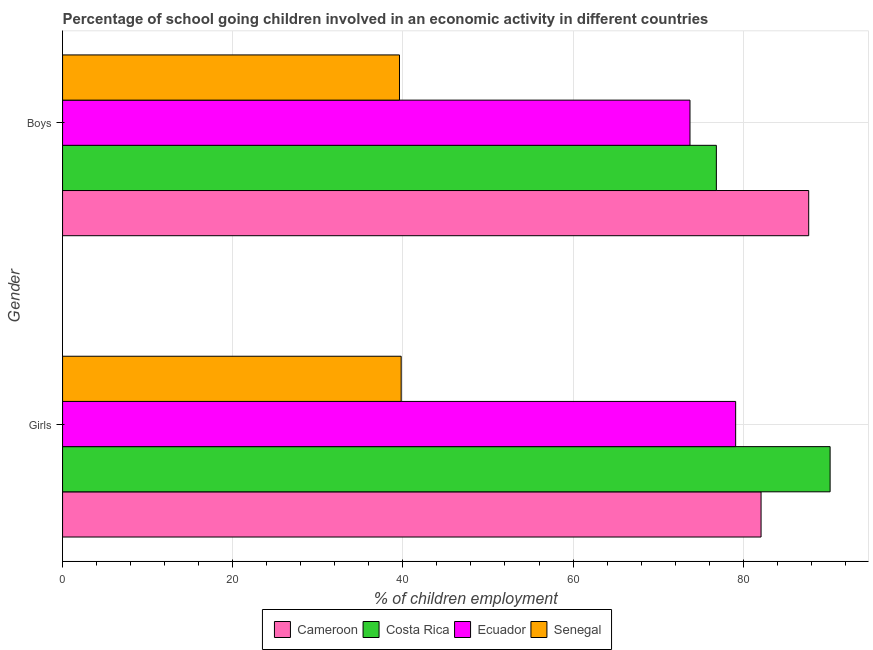Are the number of bars per tick equal to the number of legend labels?
Your response must be concise. Yes. Are the number of bars on each tick of the Y-axis equal?
Your response must be concise. Yes. What is the label of the 2nd group of bars from the top?
Ensure brevity in your answer.  Girls. What is the percentage of school going boys in Cameroon?
Give a very brief answer. 87.7. Across all countries, what is the maximum percentage of school going boys?
Offer a very short reply. 87.7. Across all countries, what is the minimum percentage of school going girls?
Provide a succinct answer. 39.8. In which country was the percentage of school going boys maximum?
Make the answer very short. Cameroon. In which country was the percentage of school going girls minimum?
Offer a terse response. Senegal. What is the total percentage of school going girls in the graph?
Provide a succinct answer. 291.23. What is the difference between the percentage of school going boys in Ecuador and that in Costa Rica?
Offer a very short reply. -3.1. What is the difference between the percentage of school going girls in Cameroon and the percentage of school going boys in Ecuador?
Give a very brief answer. 8.35. What is the average percentage of school going boys per country?
Provide a succinct answer. 69.47. What is the difference between the percentage of school going girls and percentage of school going boys in Ecuador?
Your response must be concise. 5.37. What is the ratio of the percentage of school going girls in Ecuador to that in Senegal?
Give a very brief answer. 1.99. What does the 2nd bar from the top in Girls represents?
Provide a succinct answer. Ecuador. What does the 3rd bar from the bottom in Boys represents?
Your answer should be compact. Ecuador. Are the values on the major ticks of X-axis written in scientific E-notation?
Ensure brevity in your answer.  No. Does the graph contain grids?
Ensure brevity in your answer.  Yes. How are the legend labels stacked?
Make the answer very short. Horizontal. What is the title of the graph?
Provide a succinct answer. Percentage of school going children involved in an economic activity in different countries. Does "Spain" appear as one of the legend labels in the graph?
Your answer should be compact. No. What is the label or title of the X-axis?
Offer a very short reply. % of children employment. What is the label or title of the Y-axis?
Provide a succinct answer. Gender. What is the % of children employment of Cameroon in Girls?
Your answer should be very brief. 82.1. What is the % of children employment in Costa Rica in Girls?
Offer a terse response. 90.22. What is the % of children employment of Ecuador in Girls?
Ensure brevity in your answer.  79.11. What is the % of children employment of Senegal in Girls?
Ensure brevity in your answer.  39.8. What is the % of children employment in Cameroon in Boys?
Make the answer very short. 87.7. What is the % of children employment in Costa Rica in Boys?
Provide a short and direct response. 76.85. What is the % of children employment of Ecuador in Boys?
Provide a succinct answer. 73.75. What is the % of children employment of Senegal in Boys?
Offer a terse response. 39.6. Across all Gender, what is the maximum % of children employment of Cameroon?
Provide a short and direct response. 87.7. Across all Gender, what is the maximum % of children employment of Costa Rica?
Your answer should be very brief. 90.22. Across all Gender, what is the maximum % of children employment in Ecuador?
Your answer should be compact. 79.11. Across all Gender, what is the maximum % of children employment of Senegal?
Make the answer very short. 39.8. Across all Gender, what is the minimum % of children employment of Cameroon?
Provide a short and direct response. 82.1. Across all Gender, what is the minimum % of children employment of Costa Rica?
Give a very brief answer. 76.85. Across all Gender, what is the minimum % of children employment of Ecuador?
Your response must be concise. 73.75. Across all Gender, what is the minimum % of children employment of Senegal?
Your response must be concise. 39.6. What is the total % of children employment of Cameroon in the graph?
Your answer should be compact. 169.8. What is the total % of children employment of Costa Rica in the graph?
Offer a very short reply. 167.06. What is the total % of children employment in Ecuador in the graph?
Your answer should be very brief. 152.86. What is the total % of children employment of Senegal in the graph?
Ensure brevity in your answer.  79.4. What is the difference between the % of children employment in Cameroon in Girls and that in Boys?
Your answer should be compact. -5.6. What is the difference between the % of children employment in Costa Rica in Girls and that in Boys?
Keep it short and to the point. 13.37. What is the difference between the % of children employment of Ecuador in Girls and that in Boys?
Give a very brief answer. 5.37. What is the difference between the % of children employment of Cameroon in Girls and the % of children employment of Costa Rica in Boys?
Your response must be concise. 5.25. What is the difference between the % of children employment in Cameroon in Girls and the % of children employment in Ecuador in Boys?
Your response must be concise. 8.35. What is the difference between the % of children employment of Cameroon in Girls and the % of children employment of Senegal in Boys?
Keep it short and to the point. 42.5. What is the difference between the % of children employment in Costa Rica in Girls and the % of children employment in Ecuador in Boys?
Your response must be concise. 16.47. What is the difference between the % of children employment in Costa Rica in Girls and the % of children employment in Senegal in Boys?
Provide a short and direct response. 50.62. What is the difference between the % of children employment of Ecuador in Girls and the % of children employment of Senegal in Boys?
Your answer should be compact. 39.51. What is the average % of children employment in Cameroon per Gender?
Make the answer very short. 84.9. What is the average % of children employment in Costa Rica per Gender?
Make the answer very short. 83.53. What is the average % of children employment in Ecuador per Gender?
Keep it short and to the point. 76.43. What is the average % of children employment in Senegal per Gender?
Ensure brevity in your answer.  39.7. What is the difference between the % of children employment of Cameroon and % of children employment of Costa Rica in Girls?
Give a very brief answer. -8.12. What is the difference between the % of children employment of Cameroon and % of children employment of Ecuador in Girls?
Provide a short and direct response. 2.99. What is the difference between the % of children employment of Cameroon and % of children employment of Senegal in Girls?
Your answer should be very brief. 42.3. What is the difference between the % of children employment in Costa Rica and % of children employment in Ecuador in Girls?
Offer a terse response. 11.1. What is the difference between the % of children employment in Costa Rica and % of children employment in Senegal in Girls?
Your response must be concise. 50.42. What is the difference between the % of children employment of Ecuador and % of children employment of Senegal in Girls?
Your response must be concise. 39.31. What is the difference between the % of children employment of Cameroon and % of children employment of Costa Rica in Boys?
Keep it short and to the point. 10.85. What is the difference between the % of children employment in Cameroon and % of children employment in Ecuador in Boys?
Your answer should be very brief. 13.95. What is the difference between the % of children employment of Cameroon and % of children employment of Senegal in Boys?
Ensure brevity in your answer.  48.1. What is the difference between the % of children employment of Costa Rica and % of children employment of Ecuador in Boys?
Your answer should be very brief. 3.1. What is the difference between the % of children employment of Costa Rica and % of children employment of Senegal in Boys?
Ensure brevity in your answer.  37.25. What is the difference between the % of children employment of Ecuador and % of children employment of Senegal in Boys?
Provide a short and direct response. 34.15. What is the ratio of the % of children employment in Cameroon in Girls to that in Boys?
Make the answer very short. 0.94. What is the ratio of the % of children employment in Costa Rica in Girls to that in Boys?
Make the answer very short. 1.17. What is the ratio of the % of children employment of Ecuador in Girls to that in Boys?
Your answer should be compact. 1.07. What is the ratio of the % of children employment in Senegal in Girls to that in Boys?
Offer a terse response. 1.01. What is the difference between the highest and the second highest % of children employment in Costa Rica?
Your response must be concise. 13.37. What is the difference between the highest and the second highest % of children employment of Ecuador?
Provide a succinct answer. 5.37. What is the difference between the highest and the lowest % of children employment in Costa Rica?
Provide a short and direct response. 13.37. What is the difference between the highest and the lowest % of children employment of Ecuador?
Offer a terse response. 5.37. 